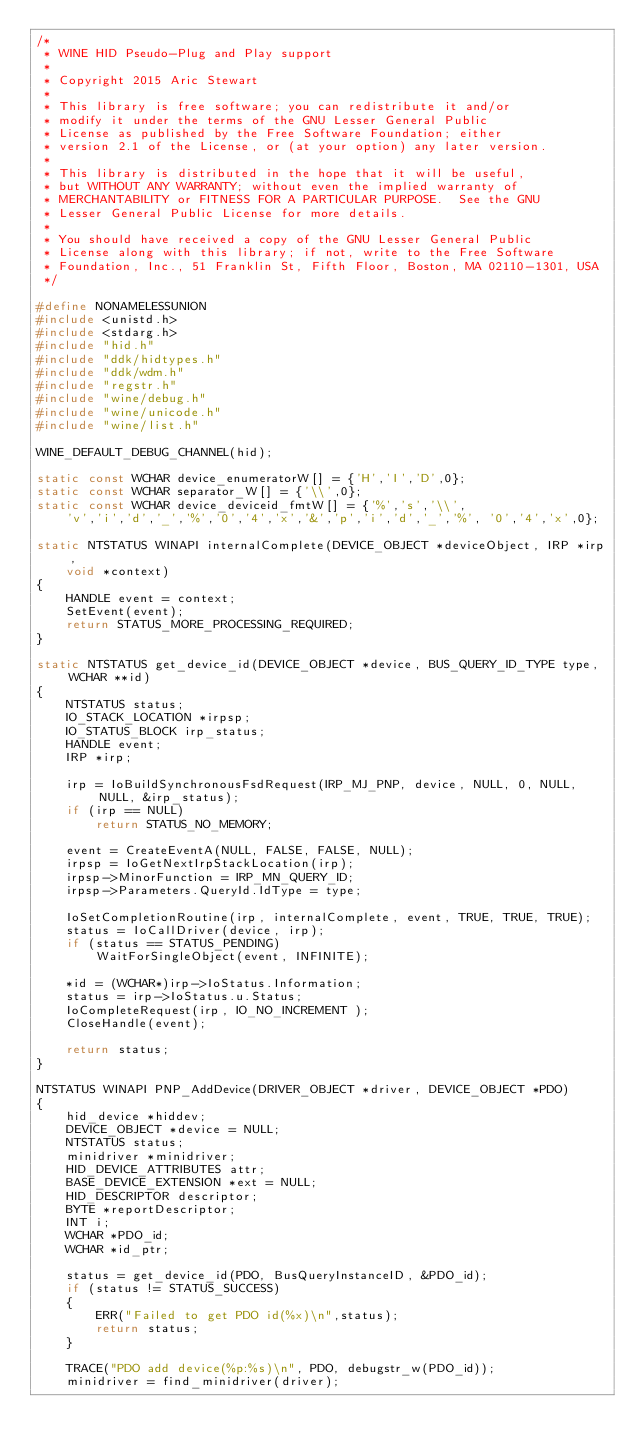Convert code to text. <code><loc_0><loc_0><loc_500><loc_500><_C_>/*
 * WINE HID Pseudo-Plug and Play support
 *
 * Copyright 2015 Aric Stewart
 *
 * This library is free software; you can redistribute it and/or
 * modify it under the terms of the GNU Lesser General Public
 * License as published by the Free Software Foundation; either
 * version 2.1 of the License, or (at your option) any later version.
 *
 * This library is distributed in the hope that it will be useful,
 * but WITHOUT ANY WARRANTY; without even the implied warranty of
 * MERCHANTABILITY or FITNESS FOR A PARTICULAR PURPOSE.  See the GNU
 * Lesser General Public License for more details.
 *
 * You should have received a copy of the GNU Lesser General Public
 * License along with this library; if not, write to the Free Software
 * Foundation, Inc., 51 Franklin St, Fifth Floor, Boston, MA 02110-1301, USA
 */

#define NONAMELESSUNION
#include <unistd.h>
#include <stdarg.h>
#include "hid.h"
#include "ddk/hidtypes.h"
#include "ddk/wdm.h"
#include "regstr.h"
#include "wine/debug.h"
#include "wine/unicode.h"
#include "wine/list.h"

WINE_DEFAULT_DEBUG_CHANNEL(hid);

static const WCHAR device_enumeratorW[] = {'H','I','D',0};
static const WCHAR separator_W[] = {'\\',0};
static const WCHAR device_deviceid_fmtW[] = {'%','s','\\',
    'v','i','d','_','%','0','4','x','&','p','i','d','_','%', '0','4','x',0};

static NTSTATUS WINAPI internalComplete(DEVICE_OBJECT *deviceObject, IRP *irp,
    void *context)
{
    HANDLE event = context;
    SetEvent(event);
    return STATUS_MORE_PROCESSING_REQUIRED;
}

static NTSTATUS get_device_id(DEVICE_OBJECT *device, BUS_QUERY_ID_TYPE type, WCHAR **id)
{
    NTSTATUS status;
    IO_STACK_LOCATION *irpsp;
    IO_STATUS_BLOCK irp_status;
    HANDLE event;
    IRP *irp;

    irp = IoBuildSynchronousFsdRequest(IRP_MJ_PNP, device, NULL, 0, NULL, NULL, &irp_status);
    if (irp == NULL)
        return STATUS_NO_MEMORY;

    event = CreateEventA(NULL, FALSE, FALSE, NULL);
    irpsp = IoGetNextIrpStackLocation(irp);
    irpsp->MinorFunction = IRP_MN_QUERY_ID;
    irpsp->Parameters.QueryId.IdType = type;

    IoSetCompletionRoutine(irp, internalComplete, event, TRUE, TRUE, TRUE);
    status = IoCallDriver(device, irp);
    if (status == STATUS_PENDING)
        WaitForSingleObject(event, INFINITE);

    *id = (WCHAR*)irp->IoStatus.Information;
    status = irp->IoStatus.u.Status;
    IoCompleteRequest(irp, IO_NO_INCREMENT );
    CloseHandle(event);

    return status;
}

NTSTATUS WINAPI PNP_AddDevice(DRIVER_OBJECT *driver, DEVICE_OBJECT *PDO)
{
    hid_device *hiddev;
    DEVICE_OBJECT *device = NULL;
    NTSTATUS status;
    minidriver *minidriver;
    HID_DEVICE_ATTRIBUTES attr;
    BASE_DEVICE_EXTENSION *ext = NULL;
    HID_DESCRIPTOR descriptor;
    BYTE *reportDescriptor;
    INT i;
    WCHAR *PDO_id;
    WCHAR *id_ptr;

    status = get_device_id(PDO, BusQueryInstanceID, &PDO_id);
    if (status != STATUS_SUCCESS)
    {
        ERR("Failed to get PDO id(%x)\n",status);
        return status;
    }

    TRACE("PDO add device(%p:%s)\n", PDO, debugstr_w(PDO_id));
    minidriver = find_minidriver(driver);
</code> 